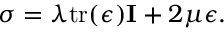Convert formula to latex. <formula><loc_0><loc_0><loc_500><loc_500>\sigma = \lambda t r ( \epsilon ) I + 2 \mu \epsilon .</formula> 